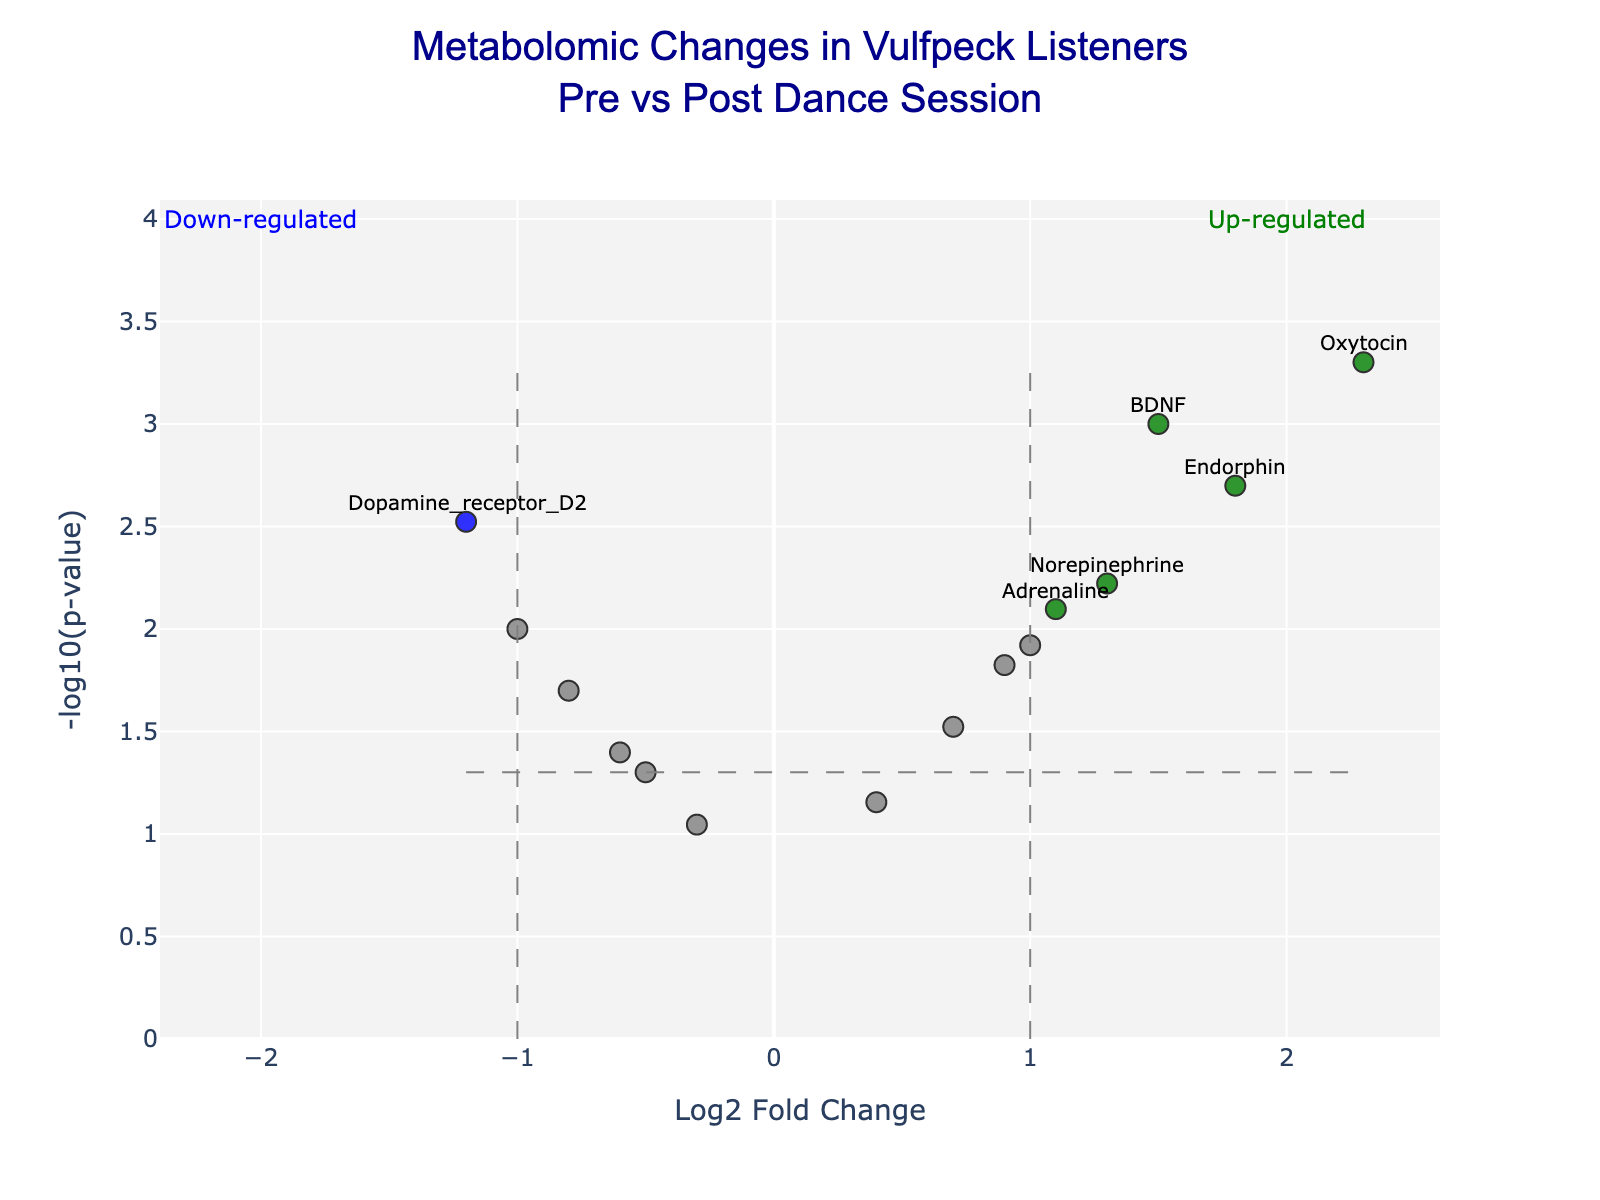How many up-regulated genes are there in the plot? Up-regulated genes are marked in green color. By counting, we can see there are 5 green points in the plot.
Answer: 5 Which gene has the highest -log10(p-value)? The gene with the highest -log10(p-value) will appear at the top of the plot. Oxytocin has the highest -log10(p-value) with a value of approximately 3.3.
Answer: Oxytocin What is the Log2FoldChange threshold used to determine significance in the plot? The vertical dashed lines indicate the Log2FoldChange thresholds. The lines are positioned at Log2FoldChange values of +1 and -1.
Answer: 1 Which gene is the most down-regulated? The most down-regulated gene will have the lowest Log2FoldChange value. Dopamine_receptor_D2 with a Log2FoldChange of -1.2 is the most down-regulated.
Answer: Dopamine_receptor_D2 What is the -log10(p-value) for Adrenaline? Locate the Adrenaline point and check its position on the y-axis. Adrenaline has a -log10(p-value) of approximately 2.1.
Answer: 2.1 Which colored points indicate statistically significant and biologically significant changes? Points colored red, green, and blue are considered significant. Green refers to up-regulated, blue to down-regulated, and red typically refers to other forms of significance not marked in the provided dataset.
Answer: Red, green, blue Are the changes in Serotonin_transporter significant? Why? Serotonin_transporter is not colored in red, green, or blue, but rather gray. It has a Log2FoldChange of 0.9 and p-value of 0.015, making it statistically significant but not biologically significant according to the threshold Log2FoldChange of 1.
Answer: No, only statistically significant Which gene shows both a significant p-value and down-regulation? Looking at the blue points which indicate down-regulation, Dopamine_receptor_D2 stands out with a Log2FoldChange of -1.2 and a significant p-value.
Answer: Dopamine_receptor_D2 What are the axis titles in the plot? The x-axis title is "Log2 Fold Change", and the y-axis title is "-log10(p-value)". Both are clearly labeled on the plot.
Answer: Log2 Fold Change and -log10(p-value) Which categories of changes are annotated in the quadrants, and what are their colors? The annotations "Up-regulated" in green and "Down-regulated" in blue appear in the top left and top right quadrants, respectively.
Answer: Up-regulated (green) and Down-regulated (blue) 